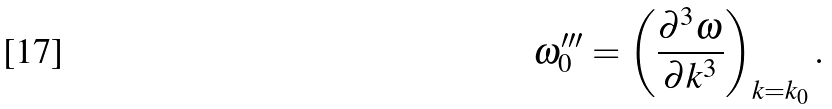Convert formula to latex. <formula><loc_0><loc_0><loc_500><loc_500>\omega _ { 0 } ^ { \prime \prime \prime } = \left ( \frac { \partial ^ { 3 } \omega } { \partial k ^ { 3 } } \right ) _ { k = k _ { 0 } } .</formula> 